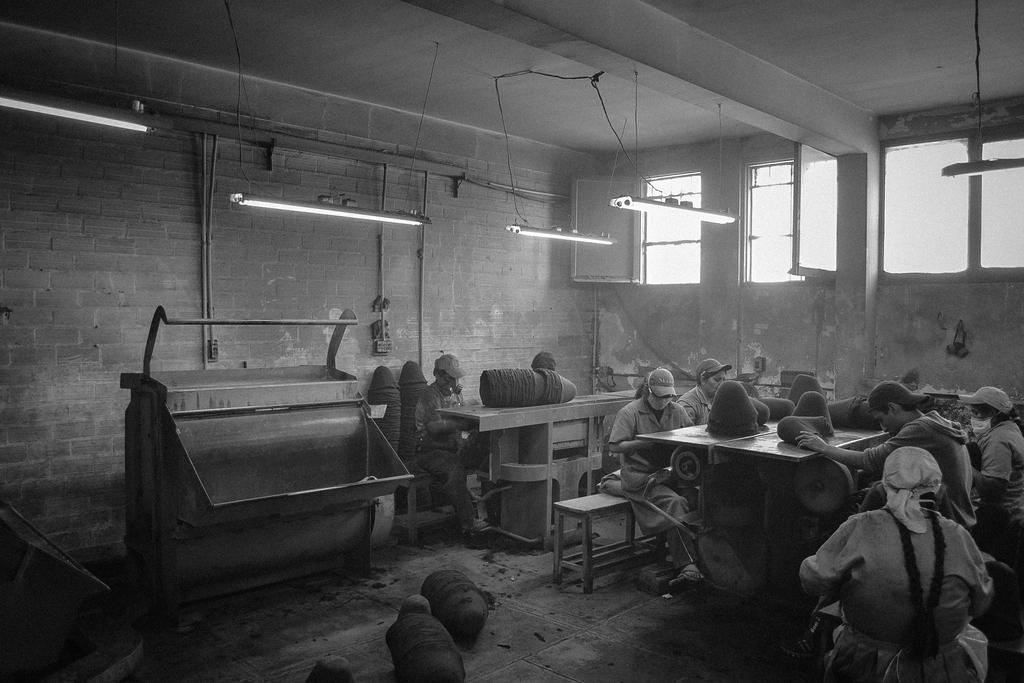What is the color scheme of the image? The image is black and white. How many people are present in the image? There are many people in the image. What are the people wearing on their heads? The people are wearing caps. What type of furniture can be seen in the image? There are tables and benches in the image. What type of lighting is present in the image? There are tube lights hanging from the ceilings. What architectural features can be seen in the image? There are windows and walls in the image. Can you tell me how many people are swimming in the image? There is no swimming activity depicted in the image; it features people wearing caps and standing near tables and benches. What type of alley is visible in the image? There is no alley present in the image; it is set indoors with walls, windows, and tube lights. 